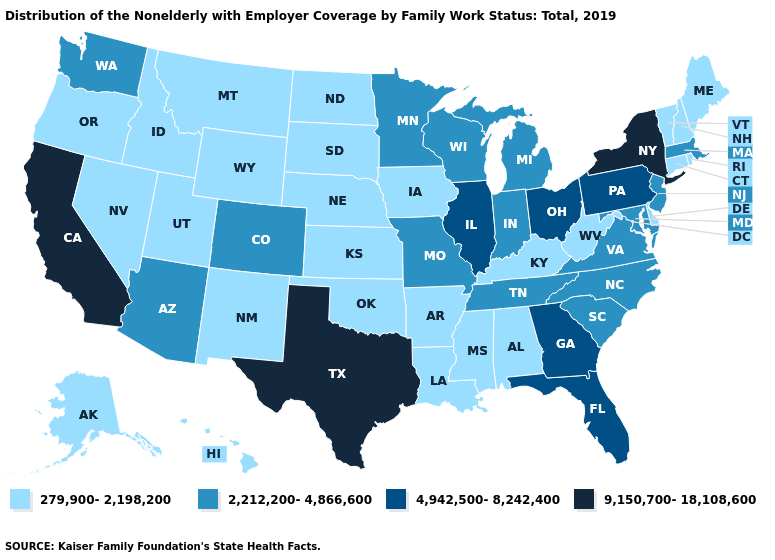Name the states that have a value in the range 279,900-2,198,200?
Give a very brief answer. Alabama, Alaska, Arkansas, Connecticut, Delaware, Hawaii, Idaho, Iowa, Kansas, Kentucky, Louisiana, Maine, Mississippi, Montana, Nebraska, Nevada, New Hampshire, New Mexico, North Dakota, Oklahoma, Oregon, Rhode Island, South Dakota, Utah, Vermont, West Virginia, Wyoming. Name the states that have a value in the range 2,212,200-4,866,600?
Write a very short answer. Arizona, Colorado, Indiana, Maryland, Massachusetts, Michigan, Minnesota, Missouri, New Jersey, North Carolina, South Carolina, Tennessee, Virginia, Washington, Wisconsin. Name the states that have a value in the range 4,942,500-8,242,400?
Answer briefly. Florida, Georgia, Illinois, Ohio, Pennsylvania. What is the highest value in the USA?
Answer briefly. 9,150,700-18,108,600. Which states have the highest value in the USA?
Give a very brief answer. California, New York, Texas. How many symbols are there in the legend?
Short answer required. 4. Does the map have missing data?
Answer briefly. No. Does Pennsylvania have the same value as Rhode Island?
Quick response, please. No. How many symbols are there in the legend?
Short answer required. 4. What is the value of Hawaii?
Be succinct. 279,900-2,198,200. What is the value of Wisconsin?
Short answer required. 2,212,200-4,866,600. Name the states that have a value in the range 9,150,700-18,108,600?
Answer briefly. California, New York, Texas. What is the value of Arizona?
Write a very short answer. 2,212,200-4,866,600. What is the value of Washington?
Concise answer only. 2,212,200-4,866,600. 